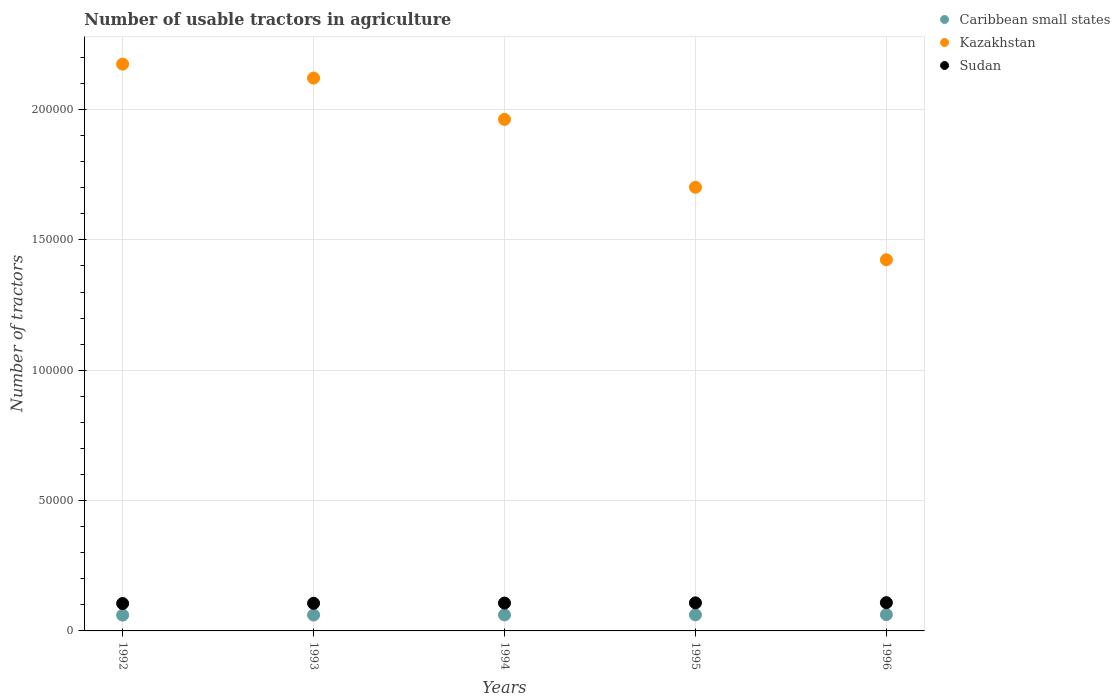Is the number of dotlines equal to the number of legend labels?
Make the answer very short. Yes. What is the number of usable tractors in agriculture in Caribbean small states in 1993?
Offer a terse response. 6104. Across all years, what is the maximum number of usable tractors in agriculture in Sudan?
Make the answer very short. 1.08e+04. Across all years, what is the minimum number of usable tractors in agriculture in Sudan?
Provide a short and direct response. 1.05e+04. In which year was the number of usable tractors in agriculture in Caribbean small states maximum?
Your answer should be very brief. 1996. In which year was the number of usable tractors in agriculture in Sudan minimum?
Make the answer very short. 1992. What is the total number of usable tractors in agriculture in Kazakhstan in the graph?
Give a very brief answer. 9.38e+05. What is the difference between the number of usable tractors in agriculture in Sudan in 1992 and that in 1996?
Give a very brief answer. -320. What is the difference between the number of usable tractors in agriculture in Sudan in 1992 and the number of usable tractors in agriculture in Caribbean small states in 1996?
Your answer should be very brief. 4272. What is the average number of usable tractors in agriculture in Sudan per year?
Provide a short and direct response. 1.07e+04. In the year 1993, what is the difference between the number of usable tractors in agriculture in Caribbean small states and number of usable tractors in agriculture in Kazakhstan?
Your response must be concise. -2.06e+05. What is the ratio of the number of usable tractors in agriculture in Kazakhstan in 1992 to that in 1996?
Ensure brevity in your answer.  1.53. Is the number of usable tractors in agriculture in Kazakhstan in 1995 less than that in 1996?
Your answer should be very brief. No. Is the difference between the number of usable tractors in agriculture in Caribbean small states in 1992 and 1995 greater than the difference between the number of usable tractors in agriculture in Kazakhstan in 1992 and 1995?
Your answer should be compact. No. What is the difference between the highest and the second highest number of usable tractors in agriculture in Caribbean small states?
Ensure brevity in your answer.  71. What is the difference between the highest and the lowest number of usable tractors in agriculture in Sudan?
Keep it short and to the point. 320. In how many years, is the number of usable tractors in agriculture in Kazakhstan greater than the average number of usable tractors in agriculture in Kazakhstan taken over all years?
Provide a succinct answer. 3. Is the sum of the number of usable tractors in agriculture in Kazakhstan in 1992 and 1993 greater than the maximum number of usable tractors in agriculture in Sudan across all years?
Provide a succinct answer. Yes. Is it the case that in every year, the sum of the number of usable tractors in agriculture in Caribbean small states and number of usable tractors in agriculture in Sudan  is greater than the number of usable tractors in agriculture in Kazakhstan?
Make the answer very short. No. Does the number of usable tractors in agriculture in Caribbean small states monotonically increase over the years?
Offer a very short reply. Yes. Is the number of usable tractors in agriculture in Sudan strictly less than the number of usable tractors in agriculture in Caribbean small states over the years?
Give a very brief answer. No. How many dotlines are there?
Your answer should be compact. 3. How many years are there in the graph?
Your answer should be very brief. 5. What is the difference between two consecutive major ticks on the Y-axis?
Provide a short and direct response. 5.00e+04. Does the graph contain grids?
Your answer should be very brief. Yes. How many legend labels are there?
Provide a succinct answer. 3. How are the legend labels stacked?
Provide a short and direct response. Vertical. What is the title of the graph?
Provide a short and direct response. Number of usable tractors in agriculture. What is the label or title of the Y-axis?
Provide a short and direct response. Number of tractors. What is the Number of tractors of Caribbean small states in 1992?
Your answer should be compact. 6069. What is the Number of tractors in Kazakhstan in 1992?
Provide a short and direct response. 2.17e+05. What is the Number of tractors of Sudan in 1992?
Your answer should be very brief. 1.05e+04. What is the Number of tractors of Caribbean small states in 1993?
Your answer should be compact. 6104. What is the Number of tractors of Kazakhstan in 1993?
Your answer should be compact. 2.12e+05. What is the Number of tractors of Sudan in 1993?
Make the answer very short. 1.06e+04. What is the Number of tractors in Caribbean small states in 1994?
Make the answer very short. 6140. What is the Number of tractors of Kazakhstan in 1994?
Your answer should be very brief. 1.96e+05. What is the Number of tractors of Sudan in 1994?
Give a very brief answer. 1.07e+04. What is the Number of tractors in Caribbean small states in 1995?
Offer a terse response. 6177. What is the Number of tractors of Kazakhstan in 1995?
Make the answer very short. 1.70e+05. What is the Number of tractors in Sudan in 1995?
Your answer should be very brief. 1.08e+04. What is the Number of tractors in Caribbean small states in 1996?
Keep it short and to the point. 6248. What is the Number of tractors of Kazakhstan in 1996?
Provide a short and direct response. 1.42e+05. What is the Number of tractors of Sudan in 1996?
Keep it short and to the point. 1.08e+04. Across all years, what is the maximum Number of tractors of Caribbean small states?
Make the answer very short. 6248. Across all years, what is the maximum Number of tractors of Kazakhstan?
Ensure brevity in your answer.  2.17e+05. Across all years, what is the maximum Number of tractors of Sudan?
Offer a terse response. 1.08e+04. Across all years, what is the minimum Number of tractors in Caribbean small states?
Your response must be concise. 6069. Across all years, what is the minimum Number of tractors of Kazakhstan?
Your response must be concise. 1.42e+05. Across all years, what is the minimum Number of tractors in Sudan?
Offer a terse response. 1.05e+04. What is the total Number of tractors of Caribbean small states in the graph?
Give a very brief answer. 3.07e+04. What is the total Number of tractors in Kazakhstan in the graph?
Keep it short and to the point. 9.38e+05. What is the total Number of tractors in Sudan in the graph?
Your answer should be very brief. 5.34e+04. What is the difference between the Number of tractors in Caribbean small states in 1992 and that in 1993?
Your response must be concise. -35. What is the difference between the Number of tractors of Kazakhstan in 1992 and that in 1993?
Provide a succinct answer. 5353. What is the difference between the Number of tractors of Sudan in 1992 and that in 1993?
Your response must be concise. -80. What is the difference between the Number of tractors in Caribbean small states in 1992 and that in 1994?
Offer a terse response. -71. What is the difference between the Number of tractors of Kazakhstan in 1992 and that in 1994?
Provide a short and direct response. 2.12e+04. What is the difference between the Number of tractors of Sudan in 1992 and that in 1994?
Give a very brief answer. -160. What is the difference between the Number of tractors of Caribbean small states in 1992 and that in 1995?
Keep it short and to the point. -108. What is the difference between the Number of tractors in Kazakhstan in 1992 and that in 1995?
Your answer should be very brief. 4.72e+04. What is the difference between the Number of tractors of Sudan in 1992 and that in 1995?
Offer a very short reply. -240. What is the difference between the Number of tractors of Caribbean small states in 1992 and that in 1996?
Offer a very short reply. -179. What is the difference between the Number of tractors of Kazakhstan in 1992 and that in 1996?
Your answer should be compact. 7.51e+04. What is the difference between the Number of tractors of Sudan in 1992 and that in 1996?
Provide a succinct answer. -320. What is the difference between the Number of tractors of Caribbean small states in 1993 and that in 1994?
Ensure brevity in your answer.  -36. What is the difference between the Number of tractors of Kazakhstan in 1993 and that in 1994?
Your answer should be compact. 1.58e+04. What is the difference between the Number of tractors of Sudan in 1993 and that in 1994?
Offer a terse response. -80. What is the difference between the Number of tractors in Caribbean small states in 1993 and that in 1995?
Offer a very short reply. -73. What is the difference between the Number of tractors of Kazakhstan in 1993 and that in 1995?
Your answer should be very brief. 4.19e+04. What is the difference between the Number of tractors in Sudan in 1993 and that in 1995?
Keep it short and to the point. -160. What is the difference between the Number of tractors in Caribbean small states in 1993 and that in 1996?
Provide a succinct answer. -144. What is the difference between the Number of tractors in Kazakhstan in 1993 and that in 1996?
Your answer should be very brief. 6.97e+04. What is the difference between the Number of tractors in Sudan in 1993 and that in 1996?
Make the answer very short. -240. What is the difference between the Number of tractors of Caribbean small states in 1994 and that in 1995?
Make the answer very short. -37. What is the difference between the Number of tractors in Kazakhstan in 1994 and that in 1995?
Give a very brief answer. 2.61e+04. What is the difference between the Number of tractors in Sudan in 1994 and that in 1995?
Give a very brief answer. -80. What is the difference between the Number of tractors in Caribbean small states in 1994 and that in 1996?
Provide a short and direct response. -108. What is the difference between the Number of tractors of Kazakhstan in 1994 and that in 1996?
Your answer should be compact. 5.39e+04. What is the difference between the Number of tractors in Sudan in 1994 and that in 1996?
Ensure brevity in your answer.  -160. What is the difference between the Number of tractors in Caribbean small states in 1995 and that in 1996?
Make the answer very short. -71. What is the difference between the Number of tractors in Kazakhstan in 1995 and that in 1996?
Your answer should be compact. 2.78e+04. What is the difference between the Number of tractors of Sudan in 1995 and that in 1996?
Provide a succinct answer. -80. What is the difference between the Number of tractors in Caribbean small states in 1992 and the Number of tractors in Kazakhstan in 1993?
Your answer should be compact. -2.06e+05. What is the difference between the Number of tractors in Caribbean small states in 1992 and the Number of tractors in Sudan in 1993?
Keep it short and to the point. -4531. What is the difference between the Number of tractors in Kazakhstan in 1992 and the Number of tractors in Sudan in 1993?
Your answer should be compact. 2.07e+05. What is the difference between the Number of tractors of Caribbean small states in 1992 and the Number of tractors of Kazakhstan in 1994?
Offer a terse response. -1.90e+05. What is the difference between the Number of tractors of Caribbean small states in 1992 and the Number of tractors of Sudan in 1994?
Give a very brief answer. -4611. What is the difference between the Number of tractors in Kazakhstan in 1992 and the Number of tractors in Sudan in 1994?
Provide a succinct answer. 2.07e+05. What is the difference between the Number of tractors of Caribbean small states in 1992 and the Number of tractors of Kazakhstan in 1995?
Provide a succinct answer. -1.64e+05. What is the difference between the Number of tractors in Caribbean small states in 1992 and the Number of tractors in Sudan in 1995?
Offer a terse response. -4691. What is the difference between the Number of tractors of Kazakhstan in 1992 and the Number of tractors of Sudan in 1995?
Ensure brevity in your answer.  2.07e+05. What is the difference between the Number of tractors in Caribbean small states in 1992 and the Number of tractors in Kazakhstan in 1996?
Provide a succinct answer. -1.36e+05. What is the difference between the Number of tractors in Caribbean small states in 1992 and the Number of tractors in Sudan in 1996?
Provide a short and direct response. -4771. What is the difference between the Number of tractors of Kazakhstan in 1992 and the Number of tractors of Sudan in 1996?
Keep it short and to the point. 2.07e+05. What is the difference between the Number of tractors in Caribbean small states in 1993 and the Number of tractors in Kazakhstan in 1994?
Keep it short and to the point. -1.90e+05. What is the difference between the Number of tractors in Caribbean small states in 1993 and the Number of tractors in Sudan in 1994?
Give a very brief answer. -4576. What is the difference between the Number of tractors in Kazakhstan in 1993 and the Number of tractors in Sudan in 1994?
Give a very brief answer. 2.01e+05. What is the difference between the Number of tractors in Caribbean small states in 1993 and the Number of tractors in Kazakhstan in 1995?
Your response must be concise. -1.64e+05. What is the difference between the Number of tractors in Caribbean small states in 1993 and the Number of tractors in Sudan in 1995?
Make the answer very short. -4656. What is the difference between the Number of tractors of Kazakhstan in 1993 and the Number of tractors of Sudan in 1995?
Offer a terse response. 2.01e+05. What is the difference between the Number of tractors of Caribbean small states in 1993 and the Number of tractors of Kazakhstan in 1996?
Keep it short and to the point. -1.36e+05. What is the difference between the Number of tractors in Caribbean small states in 1993 and the Number of tractors in Sudan in 1996?
Your response must be concise. -4736. What is the difference between the Number of tractors of Kazakhstan in 1993 and the Number of tractors of Sudan in 1996?
Ensure brevity in your answer.  2.01e+05. What is the difference between the Number of tractors in Caribbean small states in 1994 and the Number of tractors in Kazakhstan in 1995?
Make the answer very short. -1.64e+05. What is the difference between the Number of tractors of Caribbean small states in 1994 and the Number of tractors of Sudan in 1995?
Give a very brief answer. -4620. What is the difference between the Number of tractors of Kazakhstan in 1994 and the Number of tractors of Sudan in 1995?
Provide a succinct answer. 1.85e+05. What is the difference between the Number of tractors of Caribbean small states in 1994 and the Number of tractors of Kazakhstan in 1996?
Offer a terse response. -1.36e+05. What is the difference between the Number of tractors in Caribbean small states in 1994 and the Number of tractors in Sudan in 1996?
Your response must be concise. -4700. What is the difference between the Number of tractors in Kazakhstan in 1994 and the Number of tractors in Sudan in 1996?
Offer a very short reply. 1.85e+05. What is the difference between the Number of tractors in Caribbean small states in 1995 and the Number of tractors in Kazakhstan in 1996?
Your answer should be very brief. -1.36e+05. What is the difference between the Number of tractors of Caribbean small states in 1995 and the Number of tractors of Sudan in 1996?
Provide a succinct answer. -4663. What is the difference between the Number of tractors in Kazakhstan in 1995 and the Number of tractors in Sudan in 1996?
Offer a very short reply. 1.59e+05. What is the average Number of tractors in Caribbean small states per year?
Your response must be concise. 6147.6. What is the average Number of tractors of Kazakhstan per year?
Offer a very short reply. 1.88e+05. What is the average Number of tractors of Sudan per year?
Keep it short and to the point. 1.07e+04. In the year 1992, what is the difference between the Number of tractors of Caribbean small states and Number of tractors of Kazakhstan?
Make the answer very short. -2.11e+05. In the year 1992, what is the difference between the Number of tractors of Caribbean small states and Number of tractors of Sudan?
Ensure brevity in your answer.  -4451. In the year 1992, what is the difference between the Number of tractors of Kazakhstan and Number of tractors of Sudan?
Keep it short and to the point. 2.07e+05. In the year 1993, what is the difference between the Number of tractors in Caribbean small states and Number of tractors in Kazakhstan?
Provide a short and direct response. -2.06e+05. In the year 1993, what is the difference between the Number of tractors in Caribbean small states and Number of tractors in Sudan?
Your response must be concise. -4496. In the year 1993, what is the difference between the Number of tractors in Kazakhstan and Number of tractors in Sudan?
Ensure brevity in your answer.  2.01e+05. In the year 1994, what is the difference between the Number of tractors in Caribbean small states and Number of tractors in Kazakhstan?
Your answer should be compact. -1.90e+05. In the year 1994, what is the difference between the Number of tractors in Caribbean small states and Number of tractors in Sudan?
Ensure brevity in your answer.  -4540. In the year 1994, what is the difference between the Number of tractors in Kazakhstan and Number of tractors in Sudan?
Your response must be concise. 1.86e+05. In the year 1995, what is the difference between the Number of tractors in Caribbean small states and Number of tractors in Kazakhstan?
Ensure brevity in your answer.  -1.64e+05. In the year 1995, what is the difference between the Number of tractors in Caribbean small states and Number of tractors in Sudan?
Your answer should be very brief. -4583. In the year 1995, what is the difference between the Number of tractors of Kazakhstan and Number of tractors of Sudan?
Your answer should be compact. 1.59e+05. In the year 1996, what is the difference between the Number of tractors of Caribbean small states and Number of tractors of Kazakhstan?
Ensure brevity in your answer.  -1.36e+05. In the year 1996, what is the difference between the Number of tractors in Caribbean small states and Number of tractors in Sudan?
Your answer should be very brief. -4592. In the year 1996, what is the difference between the Number of tractors in Kazakhstan and Number of tractors in Sudan?
Offer a terse response. 1.32e+05. What is the ratio of the Number of tractors of Kazakhstan in 1992 to that in 1993?
Your response must be concise. 1.03. What is the ratio of the Number of tractors in Caribbean small states in 1992 to that in 1994?
Offer a very short reply. 0.99. What is the ratio of the Number of tractors of Kazakhstan in 1992 to that in 1994?
Ensure brevity in your answer.  1.11. What is the ratio of the Number of tractors in Caribbean small states in 1992 to that in 1995?
Give a very brief answer. 0.98. What is the ratio of the Number of tractors in Kazakhstan in 1992 to that in 1995?
Your response must be concise. 1.28. What is the ratio of the Number of tractors in Sudan in 1992 to that in 1995?
Offer a terse response. 0.98. What is the ratio of the Number of tractors in Caribbean small states in 1992 to that in 1996?
Offer a very short reply. 0.97. What is the ratio of the Number of tractors in Kazakhstan in 1992 to that in 1996?
Your answer should be very brief. 1.53. What is the ratio of the Number of tractors of Sudan in 1992 to that in 1996?
Ensure brevity in your answer.  0.97. What is the ratio of the Number of tractors in Caribbean small states in 1993 to that in 1994?
Offer a terse response. 0.99. What is the ratio of the Number of tractors of Kazakhstan in 1993 to that in 1994?
Your answer should be compact. 1.08. What is the ratio of the Number of tractors of Sudan in 1993 to that in 1994?
Your response must be concise. 0.99. What is the ratio of the Number of tractors of Kazakhstan in 1993 to that in 1995?
Keep it short and to the point. 1.25. What is the ratio of the Number of tractors of Sudan in 1993 to that in 1995?
Provide a succinct answer. 0.99. What is the ratio of the Number of tractors of Kazakhstan in 1993 to that in 1996?
Offer a very short reply. 1.49. What is the ratio of the Number of tractors of Sudan in 1993 to that in 1996?
Your answer should be very brief. 0.98. What is the ratio of the Number of tractors in Kazakhstan in 1994 to that in 1995?
Ensure brevity in your answer.  1.15. What is the ratio of the Number of tractors of Sudan in 1994 to that in 1995?
Ensure brevity in your answer.  0.99. What is the ratio of the Number of tractors of Caribbean small states in 1994 to that in 1996?
Make the answer very short. 0.98. What is the ratio of the Number of tractors in Kazakhstan in 1994 to that in 1996?
Ensure brevity in your answer.  1.38. What is the ratio of the Number of tractors of Sudan in 1994 to that in 1996?
Your response must be concise. 0.99. What is the ratio of the Number of tractors of Caribbean small states in 1995 to that in 1996?
Your answer should be compact. 0.99. What is the ratio of the Number of tractors of Kazakhstan in 1995 to that in 1996?
Offer a very short reply. 1.2. What is the ratio of the Number of tractors of Sudan in 1995 to that in 1996?
Ensure brevity in your answer.  0.99. What is the difference between the highest and the second highest Number of tractors of Kazakhstan?
Your answer should be compact. 5353. What is the difference between the highest and the second highest Number of tractors in Sudan?
Ensure brevity in your answer.  80. What is the difference between the highest and the lowest Number of tractors in Caribbean small states?
Offer a very short reply. 179. What is the difference between the highest and the lowest Number of tractors in Kazakhstan?
Make the answer very short. 7.51e+04. What is the difference between the highest and the lowest Number of tractors of Sudan?
Keep it short and to the point. 320. 